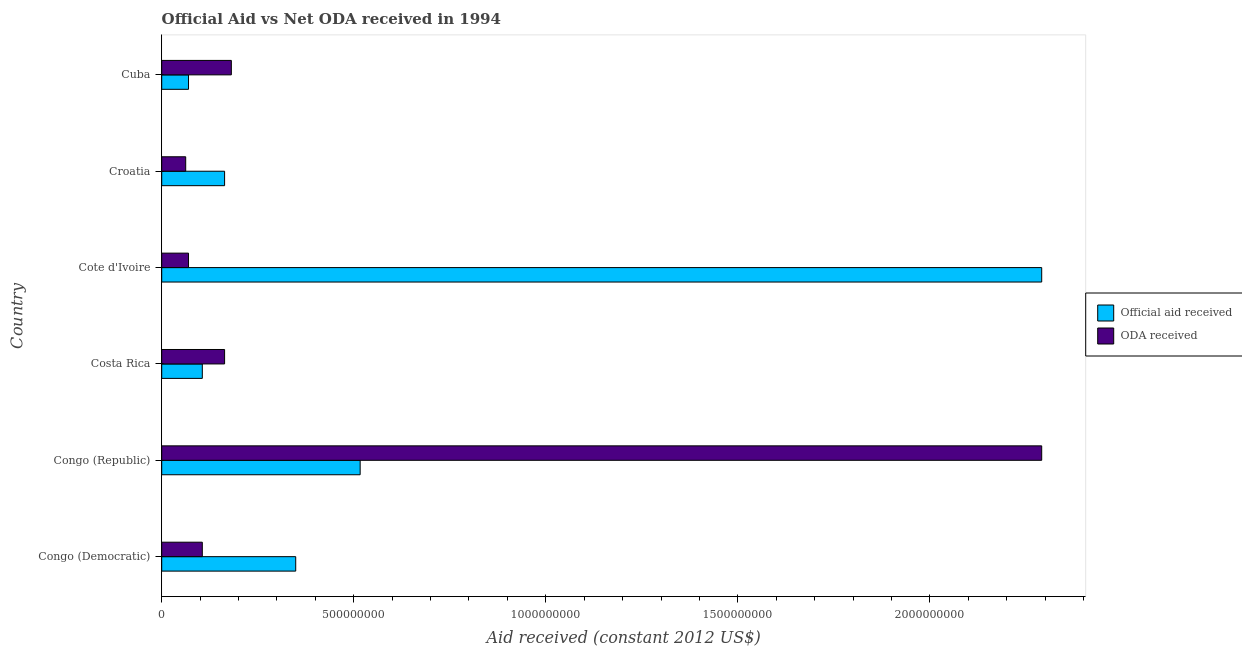How many different coloured bars are there?
Offer a very short reply. 2. Are the number of bars on each tick of the Y-axis equal?
Your answer should be compact. Yes. What is the label of the 6th group of bars from the top?
Offer a terse response. Congo (Democratic). What is the official aid received in Cote d'Ivoire?
Provide a succinct answer. 2.29e+09. Across all countries, what is the maximum oda received?
Give a very brief answer. 2.29e+09. Across all countries, what is the minimum oda received?
Offer a terse response. 6.25e+07. In which country was the official aid received maximum?
Provide a short and direct response. Cote d'Ivoire. In which country was the oda received minimum?
Keep it short and to the point. Croatia. What is the total official aid received in the graph?
Your response must be concise. 3.50e+09. What is the difference between the oda received in Cote d'Ivoire and that in Cuba?
Offer a terse response. -1.11e+08. What is the difference between the official aid received in Croatia and the oda received in Congo (Republic)?
Offer a very short reply. -2.13e+09. What is the average oda received per country?
Make the answer very short. 4.79e+08. What is the difference between the official aid received and oda received in Congo (Democratic)?
Your answer should be very brief. 2.43e+08. In how many countries, is the official aid received greater than 1400000000 US$?
Provide a succinct answer. 1. What is the ratio of the official aid received in Costa Rica to that in Cote d'Ivoire?
Your answer should be very brief. 0.05. What is the difference between the highest and the second highest official aid received?
Your answer should be very brief. 1.77e+09. What is the difference between the highest and the lowest oda received?
Ensure brevity in your answer.  2.23e+09. In how many countries, is the official aid received greater than the average official aid received taken over all countries?
Give a very brief answer. 1. What does the 2nd bar from the top in Congo (Democratic) represents?
Offer a very short reply. Official aid received. What does the 2nd bar from the bottom in Costa Rica represents?
Your response must be concise. ODA received. Are the values on the major ticks of X-axis written in scientific E-notation?
Offer a very short reply. No. Does the graph contain any zero values?
Give a very brief answer. No. Does the graph contain grids?
Make the answer very short. No. How many legend labels are there?
Your response must be concise. 2. How are the legend labels stacked?
Offer a terse response. Vertical. What is the title of the graph?
Your answer should be compact. Official Aid vs Net ODA received in 1994 . Does "Adolescent fertility rate" appear as one of the legend labels in the graph?
Give a very brief answer. No. What is the label or title of the X-axis?
Keep it short and to the point. Aid received (constant 2012 US$). What is the label or title of the Y-axis?
Your answer should be compact. Country. What is the Aid received (constant 2012 US$) of Official aid received in Congo (Democratic)?
Your answer should be compact. 3.49e+08. What is the Aid received (constant 2012 US$) in ODA received in Congo (Democratic)?
Give a very brief answer. 1.06e+08. What is the Aid received (constant 2012 US$) in Official aid received in Congo (Republic)?
Offer a terse response. 5.17e+08. What is the Aid received (constant 2012 US$) in ODA received in Congo (Republic)?
Keep it short and to the point. 2.29e+09. What is the Aid received (constant 2012 US$) in Official aid received in Costa Rica?
Provide a short and direct response. 1.06e+08. What is the Aid received (constant 2012 US$) of ODA received in Costa Rica?
Ensure brevity in your answer.  1.64e+08. What is the Aid received (constant 2012 US$) of Official aid received in Cote d'Ivoire?
Your response must be concise. 2.29e+09. What is the Aid received (constant 2012 US$) of ODA received in Cote d'Ivoire?
Give a very brief answer. 6.98e+07. What is the Aid received (constant 2012 US$) in Official aid received in Croatia?
Provide a short and direct response. 1.64e+08. What is the Aid received (constant 2012 US$) of ODA received in Croatia?
Keep it short and to the point. 6.25e+07. What is the Aid received (constant 2012 US$) in Official aid received in Cuba?
Offer a terse response. 6.98e+07. What is the Aid received (constant 2012 US$) in ODA received in Cuba?
Provide a short and direct response. 1.81e+08. Across all countries, what is the maximum Aid received (constant 2012 US$) of Official aid received?
Keep it short and to the point. 2.29e+09. Across all countries, what is the maximum Aid received (constant 2012 US$) in ODA received?
Make the answer very short. 2.29e+09. Across all countries, what is the minimum Aid received (constant 2012 US$) of Official aid received?
Offer a terse response. 6.98e+07. Across all countries, what is the minimum Aid received (constant 2012 US$) in ODA received?
Your answer should be very brief. 6.25e+07. What is the total Aid received (constant 2012 US$) in Official aid received in the graph?
Give a very brief answer. 3.50e+09. What is the total Aid received (constant 2012 US$) in ODA received in the graph?
Give a very brief answer. 2.87e+09. What is the difference between the Aid received (constant 2012 US$) in Official aid received in Congo (Democratic) and that in Congo (Republic)?
Make the answer very short. -1.68e+08. What is the difference between the Aid received (constant 2012 US$) of ODA received in Congo (Democratic) and that in Congo (Republic)?
Your answer should be very brief. -2.19e+09. What is the difference between the Aid received (constant 2012 US$) of Official aid received in Congo (Democratic) and that in Costa Rica?
Provide a succinct answer. 2.43e+08. What is the difference between the Aid received (constant 2012 US$) of ODA received in Congo (Democratic) and that in Costa Rica?
Your answer should be very brief. -5.80e+07. What is the difference between the Aid received (constant 2012 US$) of Official aid received in Congo (Democratic) and that in Cote d'Ivoire?
Ensure brevity in your answer.  -1.94e+09. What is the difference between the Aid received (constant 2012 US$) in ODA received in Congo (Democratic) and that in Cote d'Ivoire?
Ensure brevity in your answer.  3.59e+07. What is the difference between the Aid received (constant 2012 US$) in Official aid received in Congo (Democratic) and that in Croatia?
Your answer should be very brief. 1.85e+08. What is the difference between the Aid received (constant 2012 US$) of ODA received in Congo (Democratic) and that in Croatia?
Keep it short and to the point. 4.32e+07. What is the difference between the Aid received (constant 2012 US$) of Official aid received in Congo (Democratic) and that in Cuba?
Your answer should be very brief. 2.79e+08. What is the difference between the Aid received (constant 2012 US$) of ODA received in Congo (Democratic) and that in Cuba?
Your answer should be very brief. -7.56e+07. What is the difference between the Aid received (constant 2012 US$) of Official aid received in Congo (Republic) and that in Costa Rica?
Offer a terse response. 4.11e+08. What is the difference between the Aid received (constant 2012 US$) in ODA received in Congo (Republic) and that in Costa Rica?
Provide a succinct answer. 2.13e+09. What is the difference between the Aid received (constant 2012 US$) of Official aid received in Congo (Republic) and that in Cote d'Ivoire?
Provide a succinct answer. -1.77e+09. What is the difference between the Aid received (constant 2012 US$) of ODA received in Congo (Republic) and that in Cote d'Ivoire?
Give a very brief answer. 2.22e+09. What is the difference between the Aid received (constant 2012 US$) of Official aid received in Congo (Republic) and that in Croatia?
Offer a very short reply. 3.53e+08. What is the difference between the Aid received (constant 2012 US$) of ODA received in Congo (Republic) and that in Croatia?
Provide a succinct answer. 2.23e+09. What is the difference between the Aid received (constant 2012 US$) of Official aid received in Congo (Republic) and that in Cuba?
Your response must be concise. 4.47e+08. What is the difference between the Aid received (constant 2012 US$) in ODA received in Congo (Republic) and that in Cuba?
Your answer should be very brief. 2.11e+09. What is the difference between the Aid received (constant 2012 US$) of Official aid received in Costa Rica and that in Cote d'Ivoire?
Offer a terse response. -2.19e+09. What is the difference between the Aid received (constant 2012 US$) of ODA received in Costa Rica and that in Cote d'Ivoire?
Provide a succinct answer. 9.39e+07. What is the difference between the Aid received (constant 2012 US$) in Official aid received in Costa Rica and that in Croatia?
Your response must be concise. -5.80e+07. What is the difference between the Aid received (constant 2012 US$) in ODA received in Costa Rica and that in Croatia?
Your answer should be compact. 1.01e+08. What is the difference between the Aid received (constant 2012 US$) of Official aid received in Costa Rica and that in Cuba?
Offer a terse response. 3.59e+07. What is the difference between the Aid received (constant 2012 US$) in ODA received in Costa Rica and that in Cuba?
Provide a short and direct response. -1.76e+07. What is the difference between the Aid received (constant 2012 US$) in Official aid received in Cote d'Ivoire and that in Croatia?
Your answer should be very brief. 2.13e+09. What is the difference between the Aid received (constant 2012 US$) in ODA received in Cote d'Ivoire and that in Croatia?
Provide a succinct answer. 7.32e+06. What is the difference between the Aid received (constant 2012 US$) of Official aid received in Cote d'Ivoire and that in Cuba?
Keep it short and to the point. 2.22e+09. What is the difference between the Aid received (constant 2012 US$) of ODA received in Cote d'Ivoire and that in Cuba?
Offer a terse response. -1.11e+08. What is the difference between the Aid received (constant 2012 US$) of Official aid received in Croatia and that in Cuba?
Ensure brevity in your answer.  9.39e+07. What is the difference between the Aid received (constant 2012 US$) in ODA received in Croatia and that in Cuba?
Ensure brevity in your answer.  -1.19e+08. What is the difference between the Aid received (constant 2012 US$) of Official aid received in Congo (Democratic) and the Aid received (constant 2012 US$) of ODA received in Congo (Republic)?
Keep it short and to the point. -1.94e+09. What is the difference between the Aid received (constant 2012 US$) in Official aid received in Congo (Democratic) and the Aid received (constant 2012 US$) in ODA received in Costa Rica?
Ensure brevity in your answer.  1.85e+08. What is the difference between the Aid received (constant 2012 US$) in Official aid received in Congo (Democratic) and the Aid received (constant 2012 US$) in ODA received in Cote d'Ivoire?
Offer a terse response. 2.79e+08. What is the difference between the Aid received (constant 2012 US$) in Official aid received in Congo (Democratic) and the Aid received (constant 2012 US$) in ODA received in Croatia?
Make the answer very short. 2.86e+08. What is the difference between the Aid received (constant 2012 US$) in Official aid received in Congo (Democratic) and the Aid received (constant 2012 US$) in ODA received in Cuba?
Ensure brevity in your answer.  1.68e+08. What is the difference between the Aid received (constant 2012 US$) in Official aid received in Congo (Republic) and the Aid received (constant 2012 US$) in ODA received in Costa Rica?
Provide a short and direct response. 3.53e+08. What is the difference between the Aid received (constant 2012 US$) of Official aid received in Congo (Republic) and the Aid received (constant 2012 US$) of ODA received in Cote d'Ivoire?
Provide a succinct answer. 4.47e+08. What is the difference between the Aid received (constant 2012 US$) of Official aid received in Congo (Republic) and the Aid received (constant 2012 US$) of ODA received in Croatia?
Your answer should be compact. 4.54e+08. What is the difference between the Aid received (constant 2012 US$) in Official aid received in Congo (Republic) and the Aid received (constant 2012 US$) in ODA received in Cuba?
Your answer should be compact. 3.35e+08. What is the difference between the Aid received (constant 2012 US$) of Official aid received in Costa Rica and the Aid received (constant 2012 US$) of ODA received in Cote d'Ivoire?
Offer a very short reply. 3.59e+07. What is the difference between the Aid received (constant 2012 US$) of Official aid received in Costa Rica and the Aid received (constant 2012 US$) of ODA received in Croatia?
Ensure brevity in your answer.  4.32e+07. What is the difference between the Aid received (constant 2012 US$) of Official aid received in Costa Rica and the Aid received (constant 2012 US$) of ODA received in Cuba?
Provide a succinct answer. -7.56e+07. What is the difference between the Aid received (constant 2012 US$) of Official aid received in Cote d'Ivoire and the Aid received (constant 2012 US$) of ODA received in Croatia?
Keep it short and to the point. 2.23e+09. What is the difference between the Aid received (constant 2012 US$) in Official aid received in Cote d'Ivoire and the Aid received (constant 2012 US$) in ODA received in Cuba?
Your response must be concise. 2.11e+09. What is the difference between the Aid received (constant 2012 US$) of Official aid received in Croatia and the Aid received (constant 2012 US$) of ODA received in Cuba?
Make the answer very short. -1.76e+07. What is the average Aid received (constant 2012 US$) in Official aid received per country?
Provide a short and direct response. 5.83e+08. What is the average Aid received (constant 2012 US$) of ODA received per country?
Give a very brief answer. 4.79e+08. What is the difference between the Aid received (constant 2012 US$) in Official aid received and Aid received (constant 2012 US$) in ODA received in Congo (Democratic)?
Ensure brevity in your answer.  2.43e+08. What is the difference between the Aid received (constant 2012 US$) in Official aid received and Aid received (constant 2012 US$) in ODA received in Congo (Republic)?
Keep it short and to the point. -1.77e+09. What is the difference between the Aid received (constant 2012 US$) in Official aid received and Aid received (constant 2012 US$) in ODA received in Costa Rica?
Offer a terse response. -5.80e+07. What is the difference between the Aid received (constant 2012 US$) in Official aid received and Aid received (constant 2012 US$) in ODA received in Cote d'Ivoire?
Make the answer very short. 2.22e+09. What is the difference between the Aid received (constant 2012 US$) of Official aid received and Aid received (constant 2012 US$) of ODA received in Croatia?
Offer a terse response. 1.01e+08. What is the difference between the Aid received (constant 2012 US$) in Official aid received and Aid received (constant 2012 US$) in ODA received in Cuba?
Your answer should be compact. -1.11e+08. What is the ratio of the Aid received (constant 2012 US$) in Official aid received in Congo (Democratic) to that in Congo (Republic)?
Keep it short and to the point. 0.68. What is the ratio of the Aid received (constant 2012 US$) of ODA received in Congo (Democratic) to that in Congo (Republic)?
Make the answer very short. 0.05. What is the ratio of the Aid received (constant 2012 US$) of Official aid received in Congo (Democratic) to that in Costa Rica?
Offer a terse response. 3.3. What is the ratio of the Aid received (constant 2012 US$) in ODA received in Congo (Democratic) to that in Costa Rica?
Provide a succinct answer. 0.65. What is the ratio of the Aid received (constant 2012 US$) in Official aid received in Congo (Democratic) to that in Cote d'Ivoire?
Your response must be concise. 0.15. What is the ratio of the Aid received (constant 2012 US$) in ODA received in Congo (Democratic) to that in Cote d'Ivoire?
Your answer should be very brief. 1.51. What is the ratio of the Aid received (constant 2012 US$) of Official aid received in Congo (Democratic) to that in Croatia?
Provide a short and direct response. 2.13. What is the ratio of the Aid received (constant 2012 US$) of ODA received in Congo (Democratic) to that in Croatia?
Offer a very short reply. 1.69. What is the ratio of the Aid received (constant 2012 US$) of Official aid received in Congo (Democratic) to that in Cuba?
Keep it short and to the point. 5. What is the ratio of the Aid received (constant 2012 US$) in ODA received in Congo (Democratic) to that in Cuba?
Your answer should be very brief. 0.58. What is the ratio of the Aid received (constant 2012 US$) in Official aid received in Congo (Republic) to that in Costa Rica?
Provide a short and direct response. 4.89. What is the ratio of the Aid received (constant 2012 US$) of ODA received in Congo (Republic) to that in Costa Rica?
Make the answer very short. 13.99. What is the ratio of the Aid received (constant 2012 US$) of Official aid received in Congo (Republic) to that in Cote d'Ivoire?
Your answer should be very brief. 0.23. What is the ratio of the Aid received (constant 2012 US$) in ODA received in Congo (Republic) to that in Cote d'Ivoire?
Your answer should be very brief. 32.83. What is the ratio of the Aid received (constant 2012 US$) in Official aid received in Congo (Republic) to that in Croatia?
Provide a short and direct response. 3.16. What is the ratio of the Aid received (constant 2012 US$) in ODA received in Congo (Republic) to that in Croatia?
Provide a succinct answer. 36.68. What is the ratio of the Aid received (constant 2012 US$) of Official aid received in Congo (Republic) to that in Cuba?
Ensure brevity in your answer.  7.4. What is the ratio of the Aid received (constant 2012 US$) of ODA received in Congo (Republic) to that in Cuba?
Offer a terse response. 12.64. What is the ratio of the Aid received (constant 2012 US$) of Official aid received in Costa Rica to that in Cote d'Ivoire?
Your answer should be very brief. 0.05. What is the ratio of the Aid received (constant 2012 US$) in ODA received in Costa Rica to that in Cote d'Ivoire?
Give a very brief answer. 2.35. What is the ratio of the Aid received (constant 2012 US$) of Official aid received in Costa Rica to that in Croatia?
Your answer should be very brief. 0.65. What is the ratio of the Aid received (constant 2012 US$) in ODA received in Costa Rica to that in Croatia?
Ensure brevity in your answer.  2.62. What is the ratio of the Aid received (constant 2012 US$) of Official aid received in Costa Rica to that in Cuba?
Your answer should be compact. 1.51. What is the ratio of the Aid received (constant 2012 US$) of ODA received in Costa Rica to that in Cuba?
Give a very brief answer. 0.9. What is the ratio of the Aid received (constant 2012 US$) in Official aid received in Cote d'Ivoire to that in Croatia?
Make the answer very short. 13.99. What is the ratio of the Aid received (constant 2012 US$) in ODA received in Cote d'Ivoire to that in Croatia?
Ensure brevity in your answer.  1.12. What is the ratio of the Aid received (constant 2012 US$) in Official aid received in Cote d'Ivoire to that in Cuba?
Your response must be concise. 32.83. What is the ratio of the Aid received (constant 2012 US$) of ODA received in Cote d'Ivoire to that in Cuba?
Ensure brevity in your answer.  0.39. What is the ratio of the Aid received (constant 2012 US$) in Official aid received in Croatia to that in Cuba?
Offer a terse response. 2.35. What is the ratio of the Aid received (constant 2012 US$) in ODA received in Croatia to that in Cuba?
Provide a short and direct response. 0.34. What is the difference between the highest and the second highest Aid received (constant 2012 US$) in Official aid received?
Provide a short and direct response. 1.77e+09. What is the difference between the highest and the second highest Aid received (constant 2012 US$) of ODA received?
Provide a succinct answer. 2.11e+09. What is the difference between the highest and the lowest Aid received (constant 2012 US$) of Official aid received?
Your answer should be compact. 2.22e+09. What is the difference between the highest and the lowest Aid received (constant 2012 US$) of ODA received?
Your answer should be compact. 2.23e+09. 